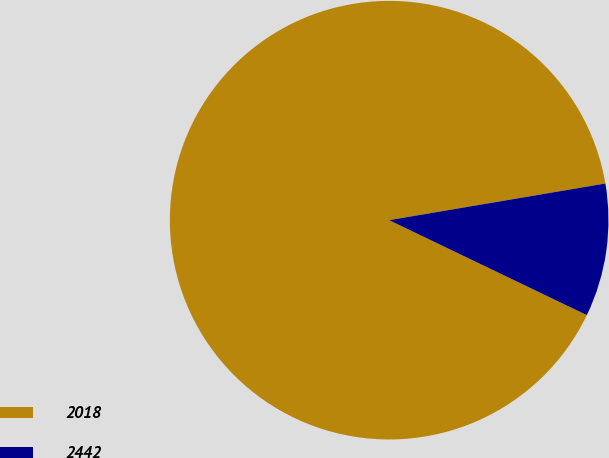<chart> <loc_0><loc_0><loc_500><loc_500><pie_chart><fcel>2018<fcel>2442<nl><fcel>90.2%<fcel>9.8%<nl></chart> 